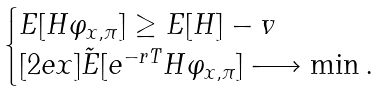<formula> <loc_0><loc_0><loc_500><loc_500>\begin{cases} E [ H \varphi _ { x , \pi } ] \geq E [ H ] - v \\ [ 2 e x ] \tilde { E } [ e ^ { - r T } H \varphi _ { x , \pi } ] \longrightarrow \min . \end{cases}</formula> 